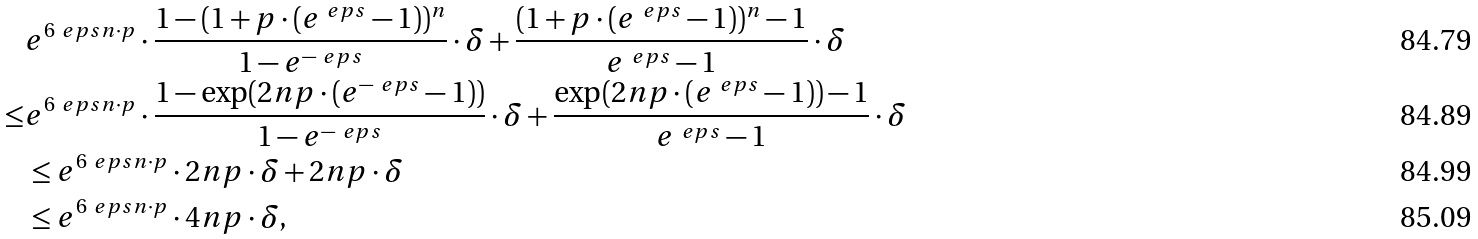Convert formula to latex. <formula><loc_0><loc_0><loc_500><loc_500>& e ^ { 6 \ e p s n \cdot p } \cdot \frac { 1 - ( 1 + p \cdot ( e ^ { \ e p s } - 1 ) ) ^ { n } } { 1 - e ^ { - \ e p s } } \cdot \delta + \frac { ( 1 + p \cdot ( e ^ { \ e p s } - 1 ) ) ^ { n } - 1 } { e ^ { \ e p s } - 1 } \cdot \delta \\ \leq & e ^ { 6 \ e p s n \cdot p } \cdot \frac { 1 - \exp ( 2 n p \cdot ( e ^ { - \ e p s } - 1 ) ) } { 1 - e ^ { - \ e p s } } \cdot \delta + \frac { \exp ( 2 n p \cdot ( e ^ { \ e p s } - 1 ) ) - 1 } { e ^ { \ e p s } - 1 } \cdot \delta \\ & \leq e ^ { 6 \ e p s n \cdot p } \cdot 2 n p \cdot \delta + 2 n p \cdot \delta \\ & \leq e ^ { 6 \ e p s n \cdot p } \cdot 4 n p \cdot \delta ,</formula> 